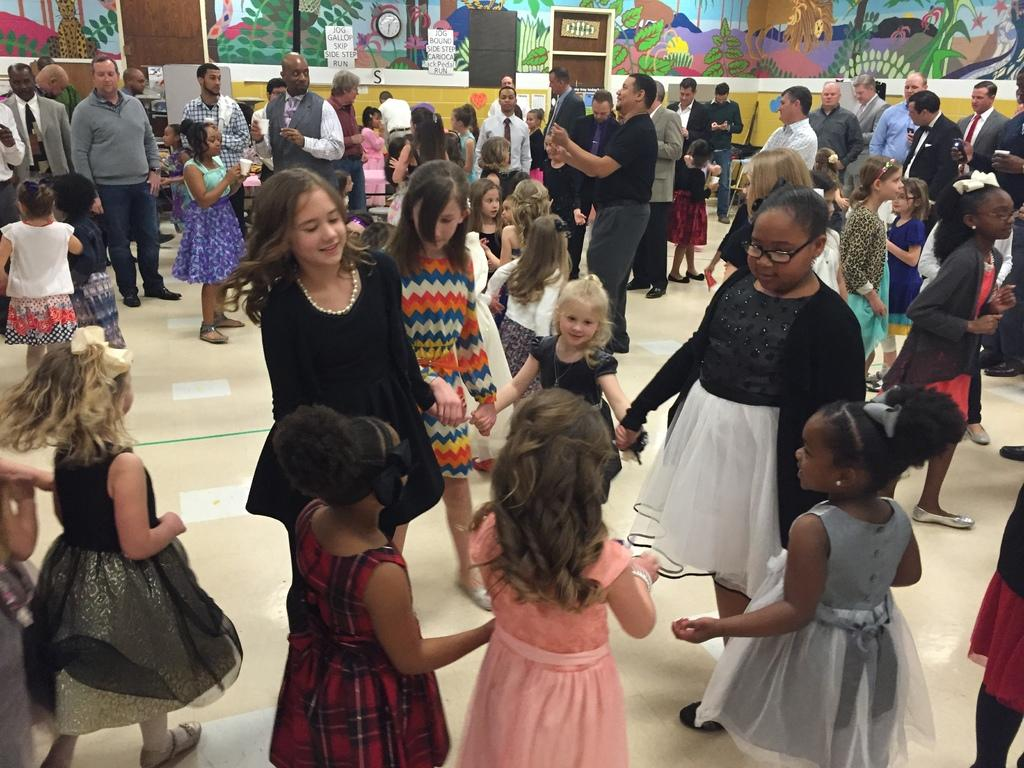What are the persons in the image doing? The persons in the image are standing and playing. What can be seen on the wall in the background? There is a painting and a clock on the wall in the background. What architectural feature is visible in the background? There are doors in the background. What type of store can be seen in the image? There is no store present in the image. What is the persons using to write on the wall in the image? There is no writing or chalk visible in the image. 